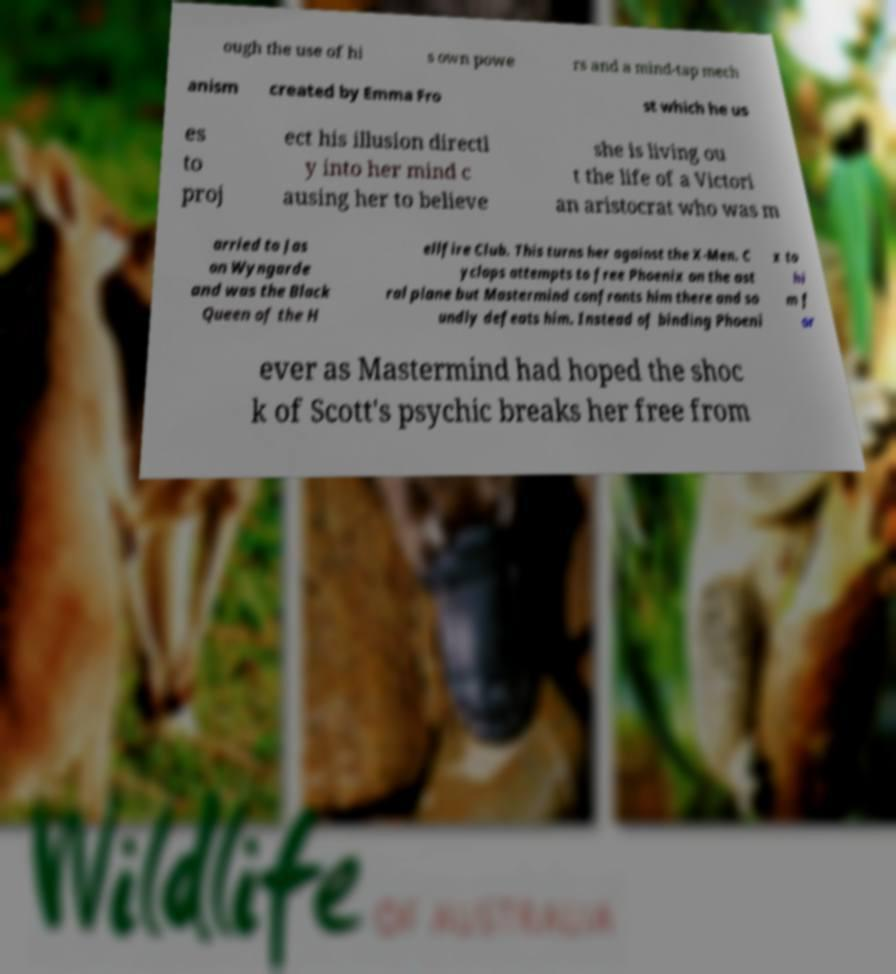For documentation purposes, I need the text within this image transcribed. Could you provide that? ough the use of hi s own powe rs and a mind-tap mech anism created by Emma Fro st which he us es to proj ect his illusion directl y into her mind c ausing her to believe she is living ou t the life of a Victori an aristocrat who was m arried to Jas on Wyngarde and was the Black Queen of the H ellfire Club. This turns her against the X-Men. C yclops attempts to free Phoenix on the ast ral plane but Mastermind confronts him there and so undly defeats him. Instead of binding Phoeni x to hi m f or ever as Mastermind had hoped the shoc k of Scott's psychic breaks her free from 